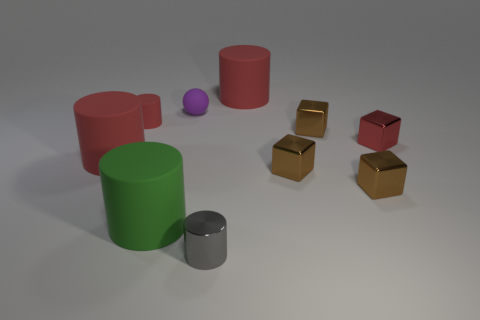How many small things are either red matte cylinders or red cubes?
Offer a terse response. 2. The small rubber cylinder is what color?
Offer a terse response. Red. There is a red matte cylinder on the left side of the tiny rubber cylinder; are there any gray shiny cylinders that are on the right side of it?
Ensure brevity in your answer.  Yes. Are there fewer tiny matte spheres to the left of the large green rubber object than brown cubes?
Your answer should be compact. Yes. Are the large red thing in front of the small purple rubber sphere and the sphere made of the same material?
Your answer should be compact. Yes. The small ball that is the same material as the big green cylinder is what color?
Provide a short and direct response. Purple. Are there fewer brown blocks in front of the gray cylinder than red blocks that are to the left of the purple object?
Your answer should be compact. No. Do the small cylinder that is to the left of the big green cylinder and the rubber cylinder that is left of the tiny red matte cylinder have the same color?
Offer a very short reply. Yes. Are there any small objects that have the same material as the large green thing?
Provide a succinct answer. Yes. What size is the shiny thing left of the red rubber object right of the tiny gray metallic thing?
Provide a short and direct response. Small. 